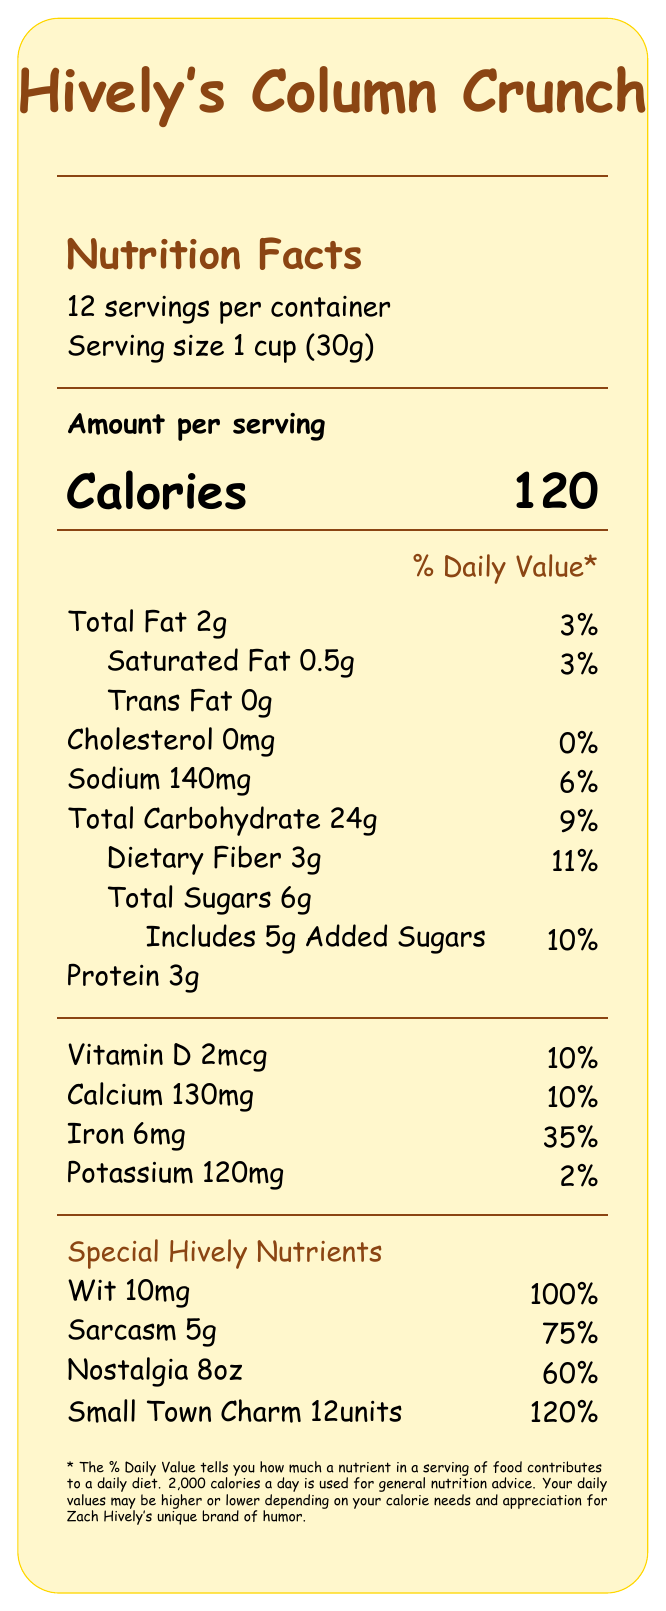what is the serving size of Hively's Column Crunch? The document states the serving size at the top as "Serving size 1 cup (30g)".
Answer: 1 cup (30g) how many servings are in a container of Hively's Column Crunch? The document clearly states "12 servings per container."
Answer: 12 servings what is the amount of protein per serving? Under the main nutrition section, protein is listed as "Protein 3g."
Answer: 3g what percentage of the daily recommended intake for iron does one serving provide? In the vitamin and mineral section, iron is listed with a daily value percentage of 35%.
Answer: 35% what is the calories per serving for Hively's Column Crunch? The document lists "Calories 120" prominently in the "Amount per serving" section.
Answer: 120 which of the following nutrients has the highest percentage of the daily value in one serving? A. Calcium B. Iron C. Sodium D. Saturated Fat The percentage of daily value for iron is 35%, which is higher than calcium (10%), sodium (6%), and saturated fat (3%).
Answer: B. Iron which special Hively nutrient is provided at 120% of the daily value? A. Wit B. Sarcasm C. Nostalgia D. Small Town Charm The special nutrient section lists "Small Town Charm" at 120%.
Answer: D. Small Town Charm is there any trans fat in Hively's Column Crunch? The document states "Trans Fat 0g" under the fat section.
Answer: No is there any added sugar in Hively's Column Crunch? It includes "5g Added Sugars" under the carbohydrates section.
Answer: Yes describe the overall nutrition profile of Hively's Column Crunch. The document provides details on both standard nutritional values and special Hively-related nutrients, along with imaginative serving suggestions that complement the humorous and heartfelt essence of Zach Hively's writing.
Answer: Hively's Column Crunch offers a balanced nutritional profile with a notable amount of protein (3g), dietary fiber (3g), and iron (35% daily value) per serving. It also provides special literary-themed nutrients like wit (100% daily value), sarcasm (75% daily value), nostalgia (60% daily value), and small-town charm (120% daily value). Each serving is 1 cup and contains 120 calories with 2g of total fat, while the cereal is brightened with literary-themed serving suggestions. what is the main flavor enhancer used in the ingredients of Hively's Column Crunch? The document lists general flavor descriptions like "natural flavors" but doesn't specify the main one.
Answer: Not enough information is the document clear about which type of dietary fiber is included in the cereal? The document only states "Dietary Fiber 3g" without specifying the type.
Answer: No 